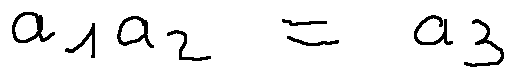Convert formula to latex. <formula><loc_0><loc_0><loc_500><loc_500>a _ { 1 } a _ { 2 } = a _ { 3 }</formula> 